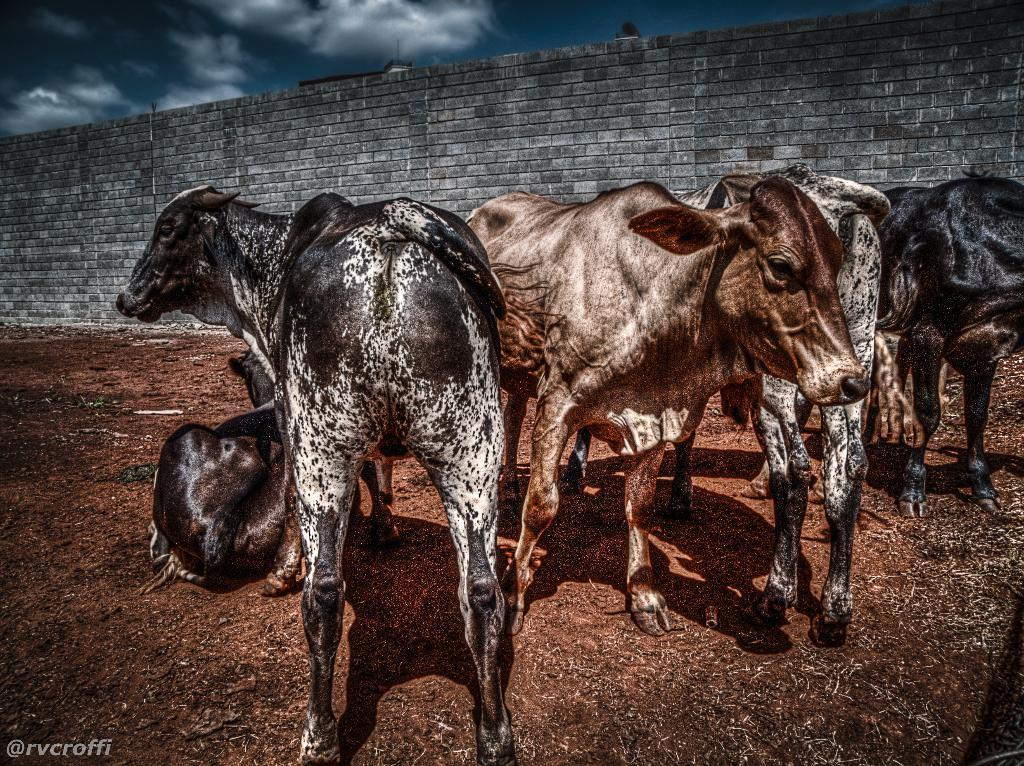What type of animals can be seen in the image? There are cows in the image. What are some of the cows doing in the image? Some cows are standing, and one cow is sitting on a muddy path. What can be seen in the background of the image? There is a wall visible in the background of the image. What is visible above the wall in the image? There are clouds in the sky above the wall. What type of mountain can be seen in the image? There is no mountain present in the image; it features cows, a wall, and clouds in the sky. Can you tell me which cow is the partner of the sitting cow in the image? There is no indication of a partnership between the cows in the image, as they are not interacting with each other. 